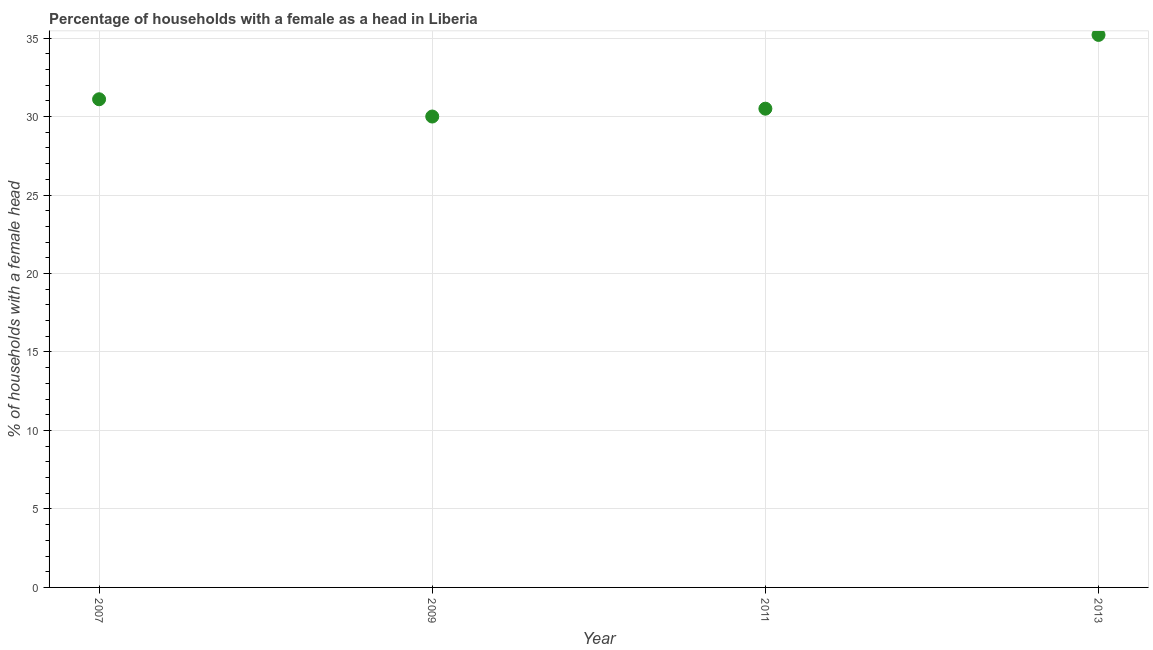What is the number of female supervised households in 2009?
Your response must be concise. 30. Across all years, what is the maximum number of female supervised households?
Offer a terse response. 35.2. In which year was the number of female supervised households maximum?
Your response must be concise. 2013. What is the sum of the number of female supervised households?
Keep it short and to the point. 126.8. What is the difference between the number of female supervised households in 2007 and 2009?
Give a very brief answer. 1.1. What is the average number of female supervised households per year?
Provide a short and direct response. 31.7. What is the median number of female supervised households?
Offer a very short reply. 30.8. In how many years, is the number of female supervised households greater than 21 %?
Your answer should be very brief. 4. What is the ratio of the number of female supervised households in 2007 to that in 2013?
Your answer should be compact. 0.88. Is the number of female supervised households in 2011 less than that in 2013?
Make the answer very short. Yes. What is the difference between the highest and the second highest number of female supervised households?
Offer a very short reply. 4.1. Is the sum of the number of female supervised households in 2009 and 2013 greater than the maximum number of female supervised households across all years?
Offer a terse response. Yes. What is the difference between the highest and the lowest number of female supervised households?
Your answer should be compact. 5.2. In how many years, is the number of female supervised households greater than the average number of female supervised households taken over all years?
Make the answer very short. 1. Does the graph contain any zero values?
Ensure brevity in your answer.  No. What is the title of the graph?
Offer a very short reply. Percentage of households with a female as a head in Liberia. What is the label or title of the Y-axis?
Make the answer very short. % of households with a female head. What is the % of households with a female head in 2007?
Ensure brevity in your answer.  31.1. What is the % of households with a female head in 2011?
Your response must be concise. 30.5. What is the % of households with a female head in 2013?
Your answer should be very brief. 35.2. What is the difference between the % of households with a female head in 2007 and 2013?
Provide a succinct answer. -4.1. What is the difference between the % of households with a female head in 2011 and 2013?
Make the answer very short. -4.7. What is the ratio of the % of households with a female head in 2007 to that in 2009?
Offer a very short reply. 1.04. What is the ratio of the % of households with a female head in 2007 to that in 2013?
Provide a succinct answer. 0.88. What is the ratio of the % of households with a female head in 2009 to that in 2013?
Ensure brevity in your answer.  0.85. What is the ratio of the % of households with a female head in 2011 to that in 2013?
Offer a terse response. 0.87. 